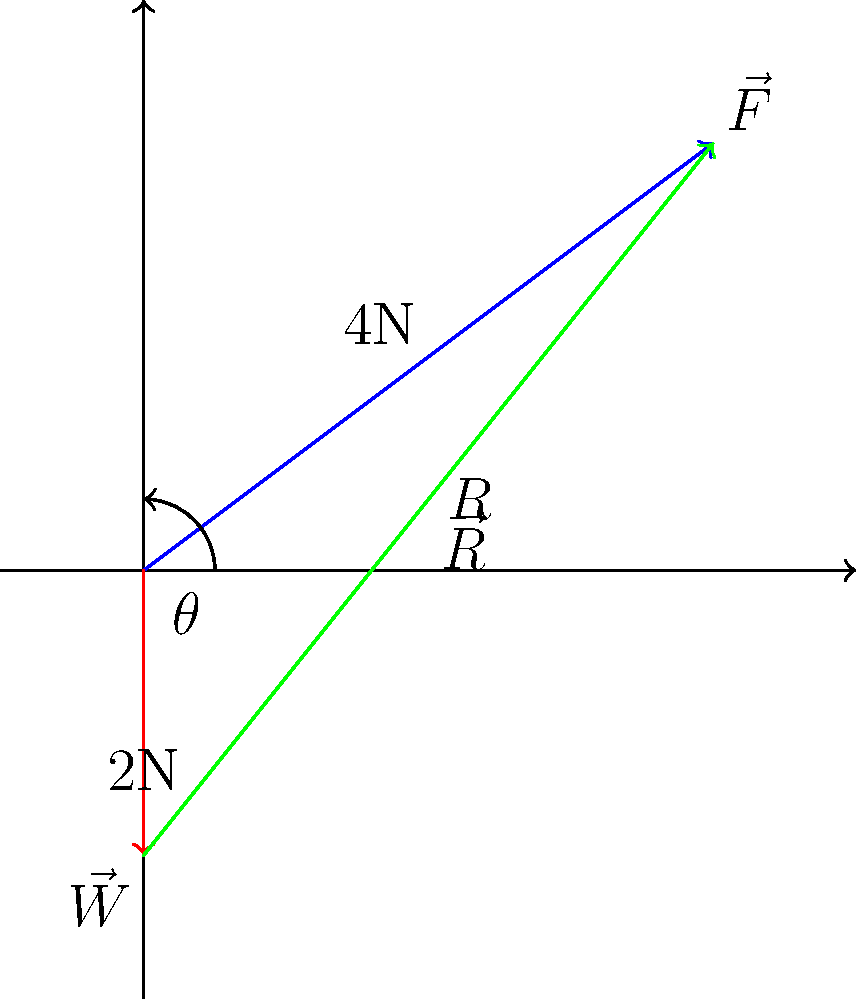A dog lands after jumping over an agility obstacle. The impact force $\vec{F}$ on the dog's front legs is 4N at an angle of 36.87° from the horizontal, while the dog's weight $\vec{W}$ is 2N acting vertically downward. Calculate the magnitude of the resultant force $\vec{R}$ exerted on the dog's joints during this impact. To solve this problem, we'll use vector addition and the Pythagorean theorem:

1) First, we identify the given information:
   - Force $\vec{F}$ has a magnitude of 4N at an angle of 36.87° from the horizontal
   - Weight $\vec{W}$ has a magnitude of 2N acting vertically downward

2) We can break down $\vec{F}$ into its horizontal and vertical components:
   $F_x = 4 \cos(36.87°) = 3.2$ N
   $F_y = 4 \sin(36.87°) = 2.4$ N

3) The resultant force $\vec{R}$ is the vector sum of $\vec{F}$ and $\vec{W}$:
   $R_x = F_x = 3.2$ N (since $\vec{W}$ has no horizontal component)
   $R_y = F_y + W = 2.4 - 2 = 0.4$ N (negative because $\vec{W}$ points downward)

4) Now we can use the Pythagorean theorem to find the magnitude of $\vec{R}$:

   $R = \sqrt{R_x^2 + R_y^2} = \sqrt{3.2^2 + 0.4^2} = \sqrt{10.24 + 0.16} = \sqrt{10.4} \approx 3.22$ N

Therefore, the magnitude of the resultant force $\vec{R}$ exerted on the dog's joints during impact is approximately 3.22 N.
Answer: $3.22$ N 